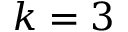<formula> <loc_0><loc_0><loc_500><loc_500>k = 3</formula> 